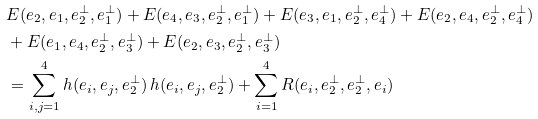<formula> <loc_0><loc_0><loc_500><loc_500>& E ( e _ { 2 } , e _ { 1 } , e _ { 2 } ^ { \perp } , e _ { 1 } ^ { \perp } ) + E ( e _ { 4 } , e _ { 3 } , e _ { 2 } ^ { \perp } , e _ { 1 } ^ { \perp } ) + E ( e _ { 3 } , e _ { 1 } , e _ { 2 } ^ { \perp } , e _ { 4 } ^ { \perp } ) + E ( e _ { 2 } , e _ { 4 } , e _ { 2 } ^ { \perp } , e _ { 4 } ^ { \perp } ) \\ & + E ( e _ { 1 } , e _ { 4 } , e _ { 2 } ^ { \perp } , e _ { 3 } ^ { \perp } ) + E ( e _ { 2 } , e _ { 3 } , e _ { 2 } ^ { \perp } , e _ { 3 } ^ { \perp } ) \\ & = \sum _ { i , j = 1 } ^ { 4 } h ( e _ { i } , e _ { j } , e _ { 2 } ^ { \perp } ) \, h ( e _ { i } , e _ { j } , e _ { 2 } ^ { \perp } ) + \sum _ { i = 1 } ^ { 4 } R ( e _ { i } , e _ { 2 } ^ { \perp } , e _ { 2 } ^ { \perp } , e _ { i } )</formula> 